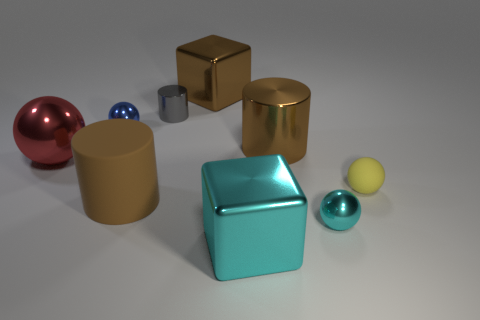Add 1 big blue metallic spheres. How many objects exist? 10 Subtract all metallic cylinders. How many cylinders are left? 1 Subtract 1 spheres. How many spheres are left? 3 Subtract all brown cylinders. How many cylinders are left? 1 Subtract all cylinders. How many objects are left? 6 Subtract all brown cylinders. Subtract all green spheres. How many cylinders are left? 1 Subtract all blue cubes. How many brown cylinders are left? 2 Subtract all large red objects. Subtract all big shiny spheres. How many objects are left? 7 Add 1 tiny metallic spheres. How many tiny metallic spheres are left? 3 Add 6 cyan rubber blocks. How many cyan rubber blocks exist? 6 